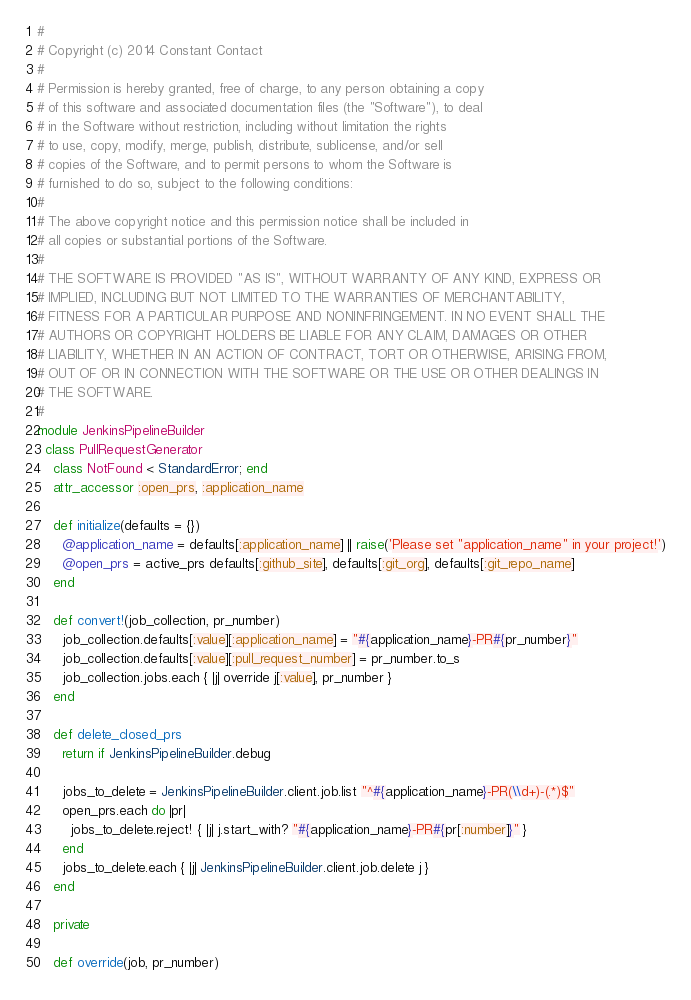<code> <loc_0><loc_0><loc_500><loc_500><_Ruby_>#
# Copyright (c) 2014 Constant Contact
#
# Permission is hereby granted, free of charge, to any person obtaining a copy
# of this software and associated documentation files (the "Software"), to deal
# in the Software without restriction, including without limitation the rights
# to use, copy, modify, merge, publish, distribute, sublicense, and/or sell
# copies of the Software, and to permit persons to whom the Software is
# furnished to do so, subject to the following conditions:
#
# The above copyright notice and this permission notice shall be included in
# all copies or substantial portions of the Software.
#
# THE SOFTWARE IS PROVIDED "AS IS", WITHOUT WARRANTY OF ANY KIND, EXPRESS OR
# IMPLIED, INCLUDING BUT NOT LIMITED TO THE WARRANTIES OF MERCHANTABILITY,
# FITNESS FOR A PARTICULAR PURPOSE AND NONINFRINGEMENT. IN NO EVENT SHALL THE
# AUTHORS OR COPYRIGHT HOLDERS BE LIABLE FOR ANY CLAIM, DAMAGES OR OTHER
# LIABILITY, WHETHER IN AN ACTION OF CONTRACT, TORT OR OTHERWISE, ARISING FROM,
# OUT OF OR IN CONNECTION WITH THE SOFTWARE OR THE USE OR OTHER DEALINGS IN
# THE SOFTWARE.
#
module JenkinsPipelineBuilder
  class PullRequestGenerator
    class NotFound < StandardError; end
    attr_accessor :open_prs, :application_name

    def initialize(defaults = {})
      @application_name = defaults[:application_name] || raise('Please set "application_name" in your project!')
      @open_prs = active_prs defaults[:github_site], defaults[:git_org], defaults[:git_repo_name]
    end

    def convert!(job_collection, pr_number)
      job_collection.defaults[:value][:application_name] = "#{application_name}-PR#{pr_number}"
      job_collection.defaults[:value][:pull_request_number] = pr_number.to_s
      job_collection.jobs.each { |j| override j[:value], pr_number }
    end

    def delete_closed_prs
      return if JenkinsPipelineBuilder.debug

      jobs_to_delete = JenkinsPipelineBuilder.client.job.list "^#{application_name}-PR(\\d+)-(.*)$"
      open_prs.each do |pr|
        jobs_to_delete.reject! { |j| j.start_with? "#{application_name}-PR#{pr[:number]}" }
      end
      jobs_to_delete.each { |j| JenkinsPipelineBuilder.client.job.delete j }
    end

    private

    def override(job, pr_number)</code> 